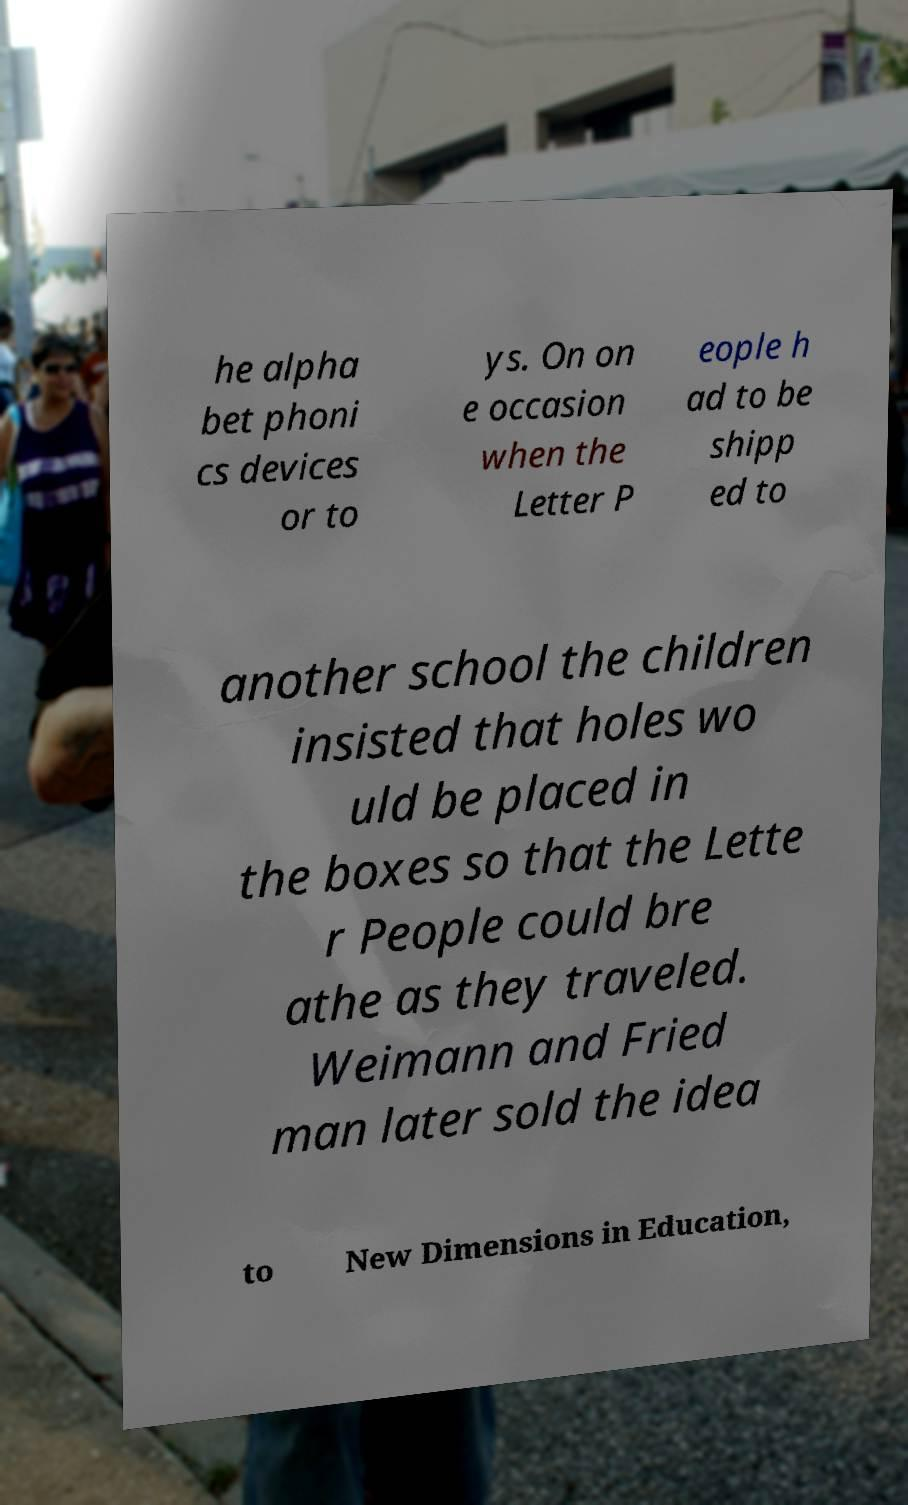Could you extract and type out the text from this image? he alpha bet phoni cs devices or to ys. On on e occasion when the Letter P eople h ad to be shipp ed to another school the children insisted that holes wo uld be placed in the boxes so that the Lette r People could bre athe as they traveled. Weimann and Fried man later sold the idea to New Dimensions in Education, 